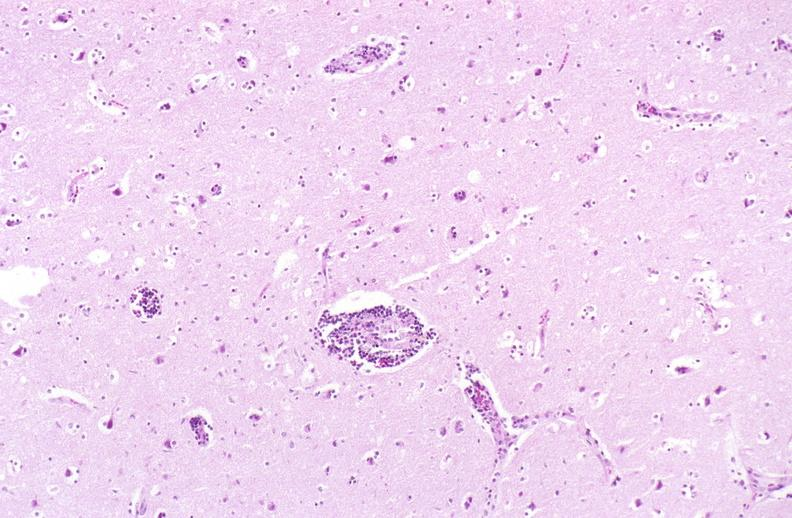does this image show brain, herpes encephalitis, perivascular cuffing?
Answer the question using a single word or phrase. Yes 